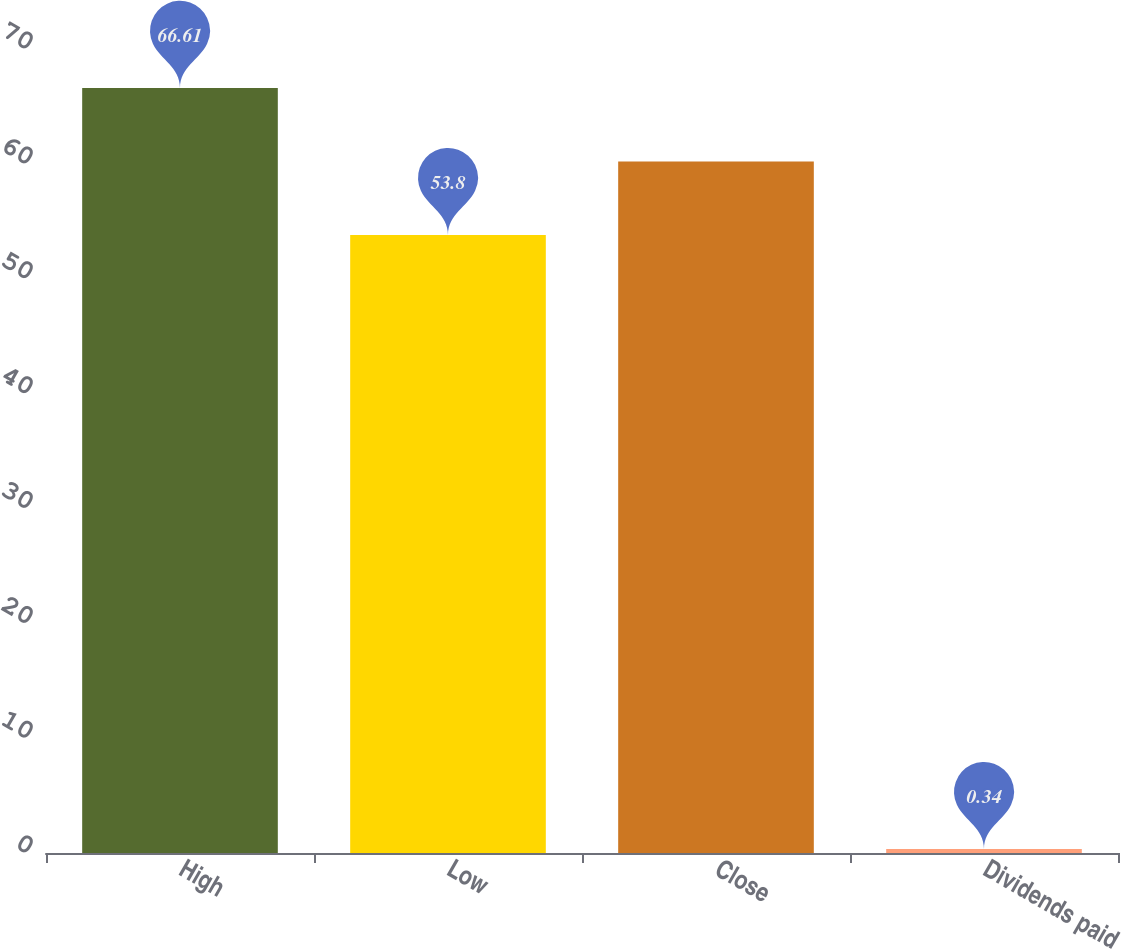Convert chart to OTSL. <chart><loc_0><loc_0><loc_500><loc_500><bar_chart><fcel>High<fcel>Low<fcel>Close<fcel>Dividends paid<nl><fcel>66.61<fcel>53.8<fcel>60.2<fcel>0.34<nl></chart> 